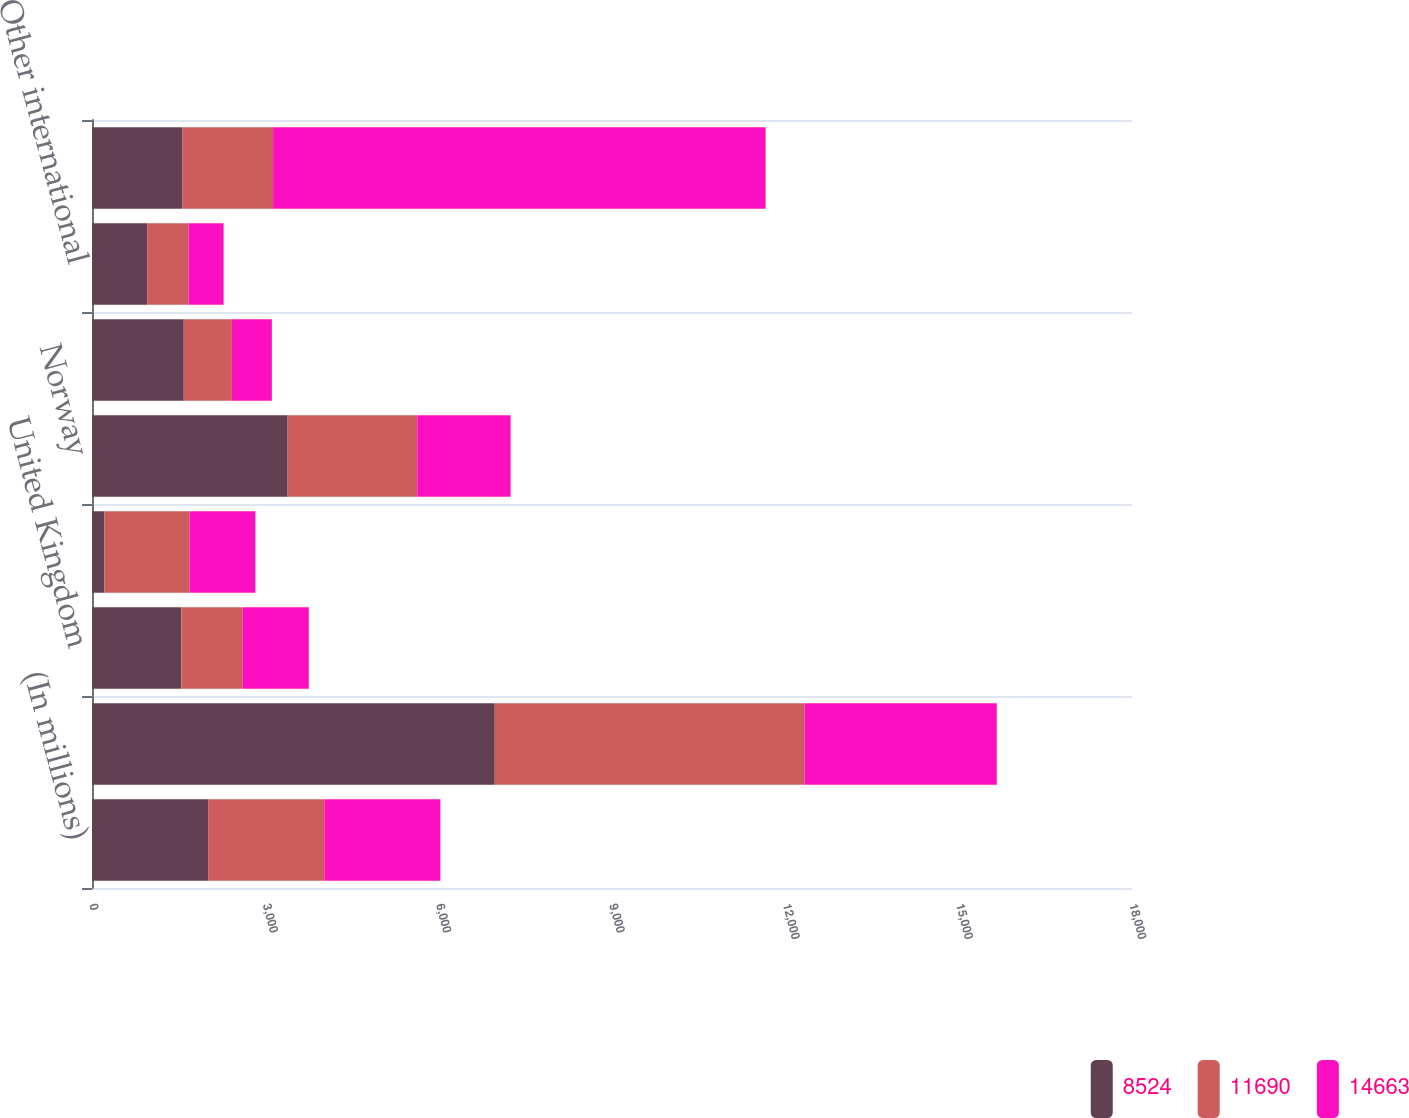Convert chart to OTSL. <chart><loc_0><loc_0><loc_500><loc_500><stacked_bar_chart><ecel><fcel>(In millions)<fcel>United States<fcel>United Kingdom<fcel>Libya (a)<fcel>Norway<fcel>Canada<fcel>Other international<fcel>Total revenues<nl><fcel>8524<fcel>2011<fcel>6971<fcel>1546<fcel>216<fcel>3386<fcel>1588<fcel>956<fcel>1567<nl><fcel>11690<fcel>2010<fcel>5363<fcel>1063<fcel>1473<fcel>2243<fcel>833<fcel>715<fcel>1567<nl><fcel>14663<fcel>2009<fcel>3326<fcel>1143<fcel>1139<fcel>1617<fcel>692<fcel>607<fcel>8524<nl></chart> 